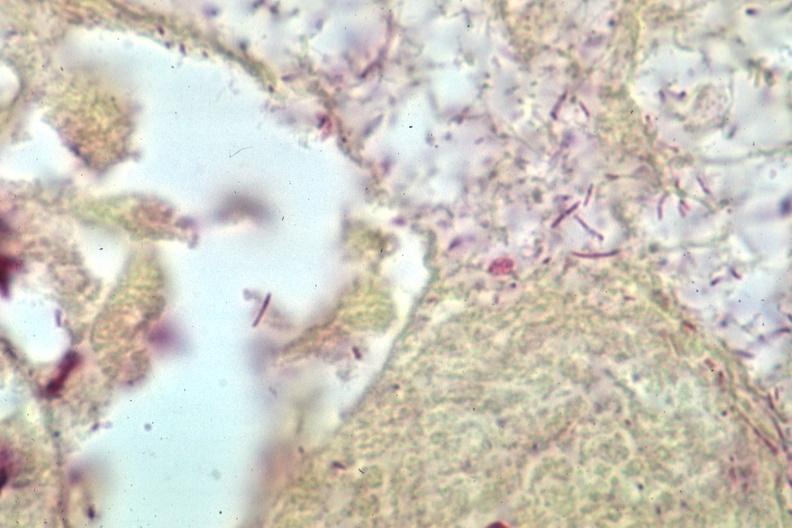what does this image show?
Answer the question using a single word or phrase. Grams stain gram negative bacteria 